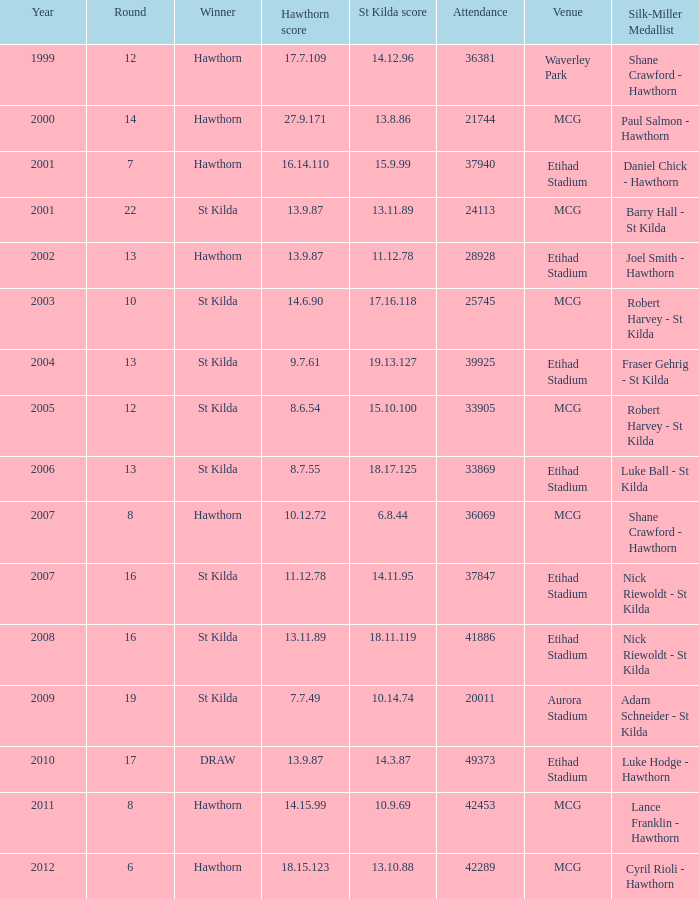109? 12.0. Write the full table. {'header': ['Year', 'Round', 'Winner', 'Hawthorn score', 'St Kilda score', 'Attendance', 'Venue', 'Silk-Miller Medallist'], 'rows': [['1999', '12', 'Hawthorn', '17.7.109', '14.12.96', '36381', 'Waverley Park', 'Shane Crawford - Hawthorn'], ['2000', '14', 'Hawthorn', '27.9.171', '13.8.86', '21744', 'MCG', 'Paul Salmon - Hawthorn'], ['2001', '7', 'Hawthorn', '16.14.110', '15.9.99', '37940', 'Etihad Stadium', 'Daniel Chick - Hawthorn'], ['2001', '22', 'St Kilda', '13.9.87', '13.11.89', '24113', 'MCG', 'Barry Hall - St Kilda'], ['2002', '13', 'Hawthorn', '13.9.87', '11.12.78', '28928', 'Etihad Stadium', 'Joel Smith - Hawthorn'], ['2003', '10', 'St Kilda', '14.6.90', '17.16.118', '25745', 'MCG', 'Robert Harvey - St Kilda'], ['2004', '13', 'St Kilda', '9.7.61', '19.13.127', '39925', 'Etihad Stadium', 'Fraser Gehrig - St Kilda'], ['2005', '12', 'St Kilda', '8.6.54', '15.10.100', '33905', 'MCG', 'Robert Harvey - St Kilda'], ['2006', '13', 'St Kilda', '8.7.55', '18.17.125', '33869', 'Etihad Stadium', 'Luke Ball - St Kilda'], ['2007', '8', 'Hawthorn', '10.12.72', '6.8.44', '36069', 'MCG', 'Shane Crawford - Hawthorn'], ['2007', '16', 'St Kilda', '11.12.78', '14.11.95', '37847', 'Etihad Stadium', 'Nick Riewoldt - St Kilda'], ['2008', '16', 'St Kilda', '13.11.89', '18.11.119', '41886', 'Etihad Stadium', 'Nick Riewoldt - St Kilda'], ['2009', '19', 'St Kilda', '7.7.49', '10.14.74', '20011', 'Aurora Stadium', 'Adam Schneider - St Kilda'], ['2010', '17', 'DRAW', '13.9.87', '14.3.87', '49373', 'Etihad Stadium', 'Luke Hodge - Hawthorn'], ['2011', '8', 'Hawthorn', '14.15.99', '10.9.69', '42453', 'MCG', 'Lance Franklin - Hawthorn'], ['2012', '6', 'Hawthorn', '18.15.123', '13.10.88', '42289', 'MCG', 'Cyril Rioli - Hawthorn']]} 